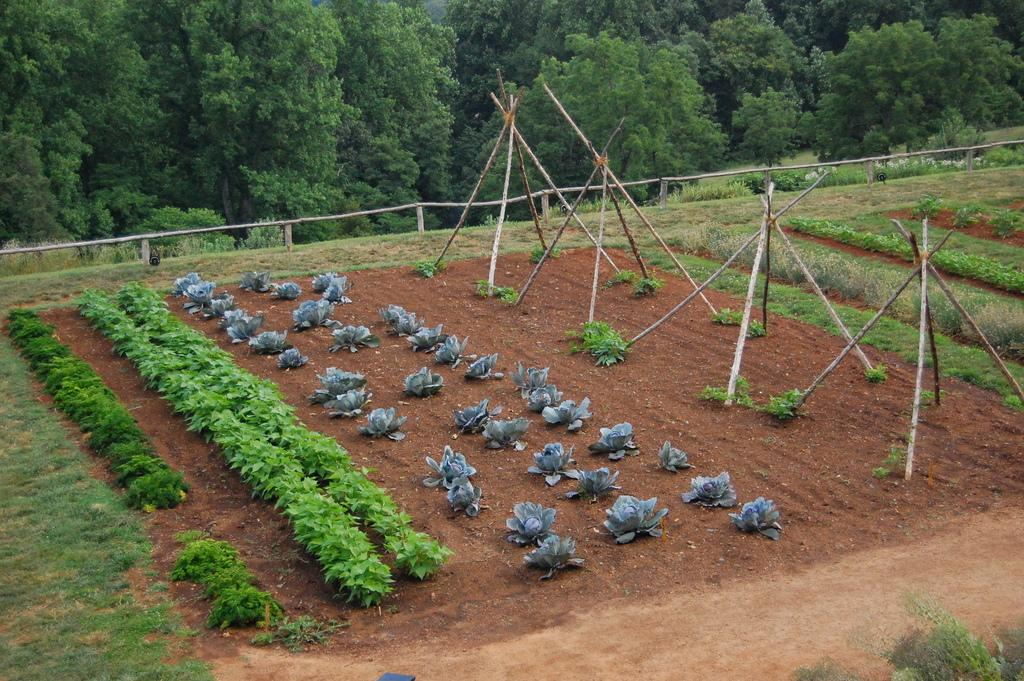What type of surface is at the bottom of the image? There is sand and grass at the bottom of the image. What other elements can be seen at the bottom of the image? There are plants and wooden sticks at the bottom of the image. What can be seen in the background of the image? There is a fence and trees in the background of the image. How does the digestion process of the plants in the image work? The image does not provide information about the digestion process of the plants; it only shows their presence in the image. 